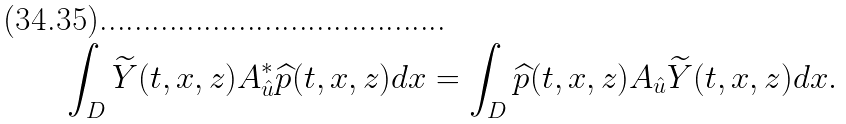<formula> <loc_0><loc_0><loc_500><loc_500>\int _ { D } \widetilde { Y } ( t , x , z ) A _ { \hat { u } } ^ { * } \widehat { p } ( t , x , z ) d x = \int _ { D } \widehat { p } ( t , x , z ) A _ { \hat { u } } \widetilde { Y } ( t , x , z ) d x .</formula> 